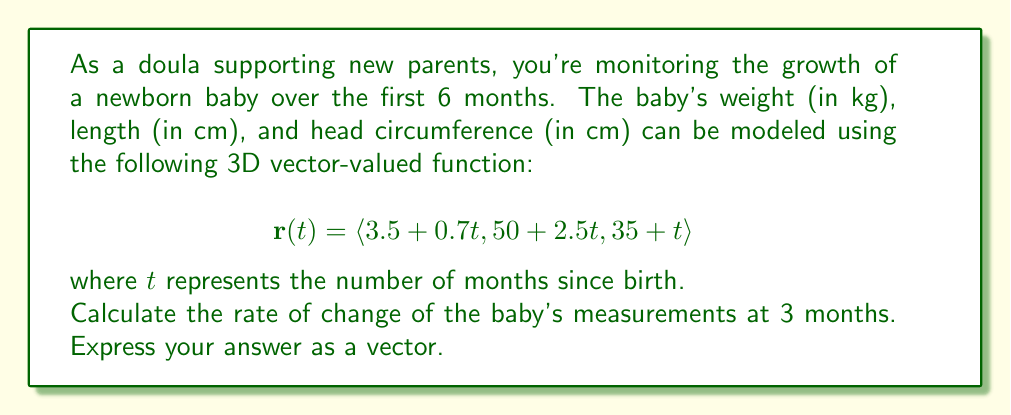Can you answer this question? To solve this problem, we need to find the derivative of the vector-valued function $\mathbf{r}(t)$ and evaluate it at $t = 3$ months. This will give us the instantaneous rate of change for each measurement at 3 months.

Step 1: Find the derivative of $\mathbf{r}(t)$.
The derivative of a vector-valued function is obtained by differentiating each component separately:

$$\mathbf{r}'(t) = \langle \frac{d}{dt}(3.5 + 0.7t), \frac{d}{dt}(50 + 2.5t), \frac{d}{dt}(35 + t) \rangle$$

$$\mathbf{r}'(t) = \langle 0.7, 2.5, 1 \rangle$$

Step 2: Evaluate $\mathbf{r}'(t)$ at $t = 3$ months.
Since $\mathbf{r}'(t)$ is constant (it doesn't depend on $t$), its value at $t = 3$ is the same as the general expression:

$$\mathbf{r}'(3) = \langle 0.7, 2.5, 1 \rangle$$

This result means that at 3 months:
- The baby's weight is increasing at a rate of 0.7 kg per month
- The baby's length is increasing at a rate of 2.5 cm per month
- The baby's head circumference is increasing at a rate of 1 cm per month
Answer: $\langle 0.7, 2.5, 1 \rangle$ 